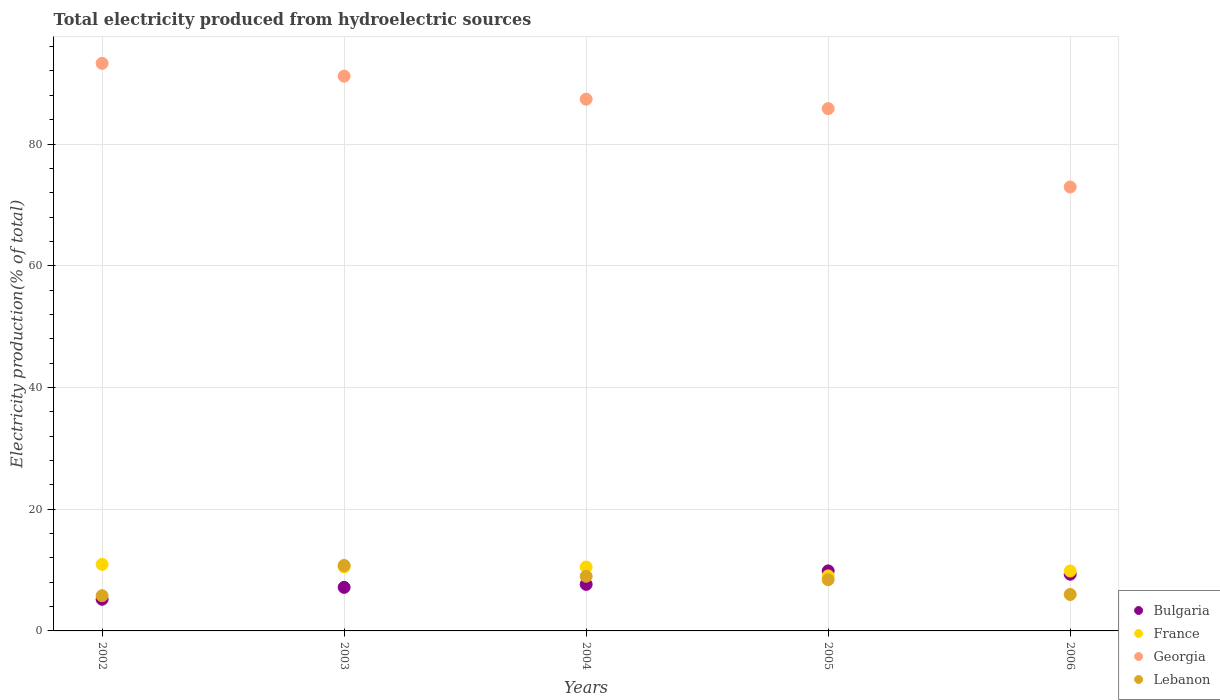How many different coloured dotlines are there?
Your answer should be compact. 4. What is the total electricity produced in Bulgaria in 2005?
Your response must be concise. 9.86. Across all years, what is the maximum total electricity produced in Bulgaria?
Your answer should be compact. 9.86. Across all years, what is the minimum total electricity produced in Bulgaria?
Offer a very short reply. 5.2. In which year was the total electricity produced in Georgia maximum?
Provide a succinct answer. 2002. What is the total total electricity produced in Bulgaria in the graph?
Your answer should be very brief. 39.18. What is the difference between the total electricity produced in France in 2004 and that in 2006?
Your response must be concise. 0.66. What is the difference between the total electricity produced in Georgia in 2006 and the total electricity produced in France in 2004?
Keep it short and to the point. 62.43. What is the average total electricity produced in Bulgaria per year?
Make the answer very short. 7.84. In the year 2003, what is the difference between the total electricity produced in Georgia and total electricity produced in Bulgaria?
Your answer should be very brief. 83.99. In how many years, is the total electricity produced in Lebanon greater than 16 %?
Give a very brief answer. 0. What is the ratio of the total electricity produced in Bulgaria in 2002 to that in 2006?
Provide a short and direct response. 0.56. Is the total electricity produced in Lebanon in 2003 less than that in 2004?
Make the answer very short. No. Is the difference between the total electricity produced in Georgia in 2004 and 2006 greater than the difference between the total electricity produced in Bulgaria in 2004 and 2006?
Keep it short and to the point. Yes. What is the difference between the highest and the second highest total electricity produced in Bulgaria?
Make the answer very short. 0.55. What is the difference between the highest and the lowest total electricity produced in Bulgaria?
Your answer should be compact. 4.66. In how many years, is the total electricity produced in Georgia greater than the average total electricity produced in Georgia taken over all years?
Make the answer very short. 3. Is the sum of the total electricity produced in Lebanon in 2003 and 2006 greater than the maximum total electricity produced in Bulgaria across all years?
Make the answer very short. Yes. Is it the case that in every year, the sum of the total electricity produced in Georgia and total electricity produced in France  is greater than the sum of total electricity produced in Bulgaria and total electricity produced in Lebanon?
Make the answer very short. Yes. Does the total electricity produced in Bulgaria monotonically increase over the years?
Offer a very short reply. No. Is the total electricity produced in Georgia strictly less than the total electricity produced in France over the years?
Ensure brevity in your answer.  No. How many dotlines are there?
Your answer should be compact. 4. What is the difference between two consecutive major ticks on the Y-axis?
Provide a succinct answer. 20. Does the graph contain grids?
Offer a very short reply. Yes. How many legend labels are there?
Your answer should be very brief. 4. What is the title of the graph?
Keep it short and to the point. Total electricity produced from hydroelectric sources. Does "Curacao" appear as one of the legend labels in the graph?
Make the answer very short. No. What is the label or title of the X-axis?
Your answer should be compact. Years. What is the label or title of the Y-axis?
Provide a short and direct response. Electricity production(% of total). What is the Electricity production(% of total) in Bulgaria in 2002?
Offer a terse response. 5.2. What is the Electricity production(% of total) in France in 2002?
Provide a short and direct response. 10.93. What is the Electricity production(% of total) in Georgia in 2002?
Offer a very short reply. 93.25. What is the Electricity production(% of total) in Lebanon in 2002?
Ensure brevity in your answer.  5.78. What is the Electricity production(% of total) of Bulgaria in 2003?
Keep it short and to the point. 7.16. What is the Electricity production(% of total) of France in 2003?
Your answer should be compact. 10.51. What is the Electricity production(% of total) of Georgia in 2003?
Provide a succinct answer. 91.15. What is the Electricity production(% of total) in Lebanon in 2003?
Make the answer very short. 10.75. What is the Electricity production(% of total) of Bulgaria in 2004?
Ensure brevity in your answer.  7.65. What is the Electricity production(% of total) of France in 2004?
Keep it short and to the point. 10.51. What is the Electricity production(% of total) in Georgia in 2004?
Provide a succinct answer. 87.36. What is the Electricity production(% of total) in Lebanon in 2004?
Offer a very short reply. 8.98. What is the Electricity production(% of total) in Bulgaria in 2005?
Provide a succinct answer. 9.86. What is the Electricity production(% of total) of France in 2005?
Make the answer very short. 9.04. What is the Electricity production(% of total) of Georgia in 2005?
Ensure brevity in your answer.  85.81. What is the Electricity production(% of total) of Lebanon in 2005?
Your response must be concise. 8.41. What is the Electricity production(% of total) in Bulgaria in 2006?
Ensure brevity in your answer.  9.31. What is the Electricity production(% of total) in France in 2006?
Keep it short and to the point. 9.85. What is the Electricity production(% of total) of Georgia in 2006?
Give a very brief answer. 72.94. What is the Electricity production(% of total) in Lebanon in 2006?
Give a very brief answer. 5.99. Across all years, what is the maximum Electricity production(% of total) in Bulgaria?
Offer a terse response. 9.86. Across all years, what is the maximum Electricity production(% of total) of France?
Provide a succinct answer. 10.93. Across all years, what is the maximum Electricity production(% of total) of Georgia?
Keep it short and to the point. 93.25. Across all years, what is the maximum Electricity production(% of total) of Lebanon?
Your response must be concise. 10.75. Across all years, what is the minimum Electricity production(% of total) of Bulgaria?
Provide a short and direct response. 5.2. Across all years, what is the minimum Electricity production(% of total) of France?
Give a very brief answer. 9.04. Across all years, what is the minimum Electricity production(% of total) in Georgia?
Your answer should be very brief. 72.94. Across all years, what is the minimum Electricity production(% of total) in Lebanon?
Offer a very short reply. 5.78. What is the total Electricity production(% of total) in Bulgaria in the graph?
Ensure brevity in your answer.  39.18. What is the total Electricity production(% of total) of France in the graph?
Your answer should be compact. 50.83. What is the total Electricity production(% of total) of Georgia in the graph?
Make the answer very short. 430.51. What is the total Electricity production(% of total) in Lebanon in the graph?
Ensure brevity in your answer.  39.91. What is the difference between the Electricity production(% of total) of Bulgaria in 2002 and that in 2003?
Provide a succinct answer. -1.95. What is the difference between the Electricity production(% of total) in France in 2002 and that in 2003?
Give a very brief answer. 0.42. What is the difference between the Electricity production(% of total) in Georgia in 2002 and that in 2003?
Your response must be concise. 2.1. What is the difference between the Electricity production(% of total) of Lebanon in 2002 and that in 2003?
Ensure brevity in your answer.  -4.97. What is the difference between the Electricity production(% of total) in Bulgaria in 2002 and that in 2004?
Provide a short and direct response. -2.44. What is the difference between the Electricity production(% of total) of France in 2002 and that in 2004?
Give a very brief answer. 0.42. What is the difference between the Electricity production(% of total) of Georgia in 2002 and that in 2004?
Make the answer very short. 5.89. What is the difference between the Electricity production(% of total) of Lebanon in 2002 and that in 2004?
Offer a very short reply. -3.19. What is the difference between the Electricity production(% of total) in Bulgaria in 2002 and that in 2005?
Provide a short and direct response. -4.66. What is the difference between the Electricity production(% of total) of France in 2002 and that in 2005?
Provide a succinct answer. 1.89. What is the difference between the Electricity production(% of total) of Georgia in 2002 and that in 2005?
Your answer should be very brief. 7.44. What is the difference between the Electricity production(% of total) of Lebanon in 2002 and that in 2005?
Keep it short and to the point. -2.63. What is the difference between the Electricity production(% of total) of Bulgaria in 2002 and that in 2006?
Give a very brief answer. -4.11. What is the difference between the Electricity production(% of total) of France in 2002 and that in 2006?
Give a very brief answer. 1.08. What is the difference between the Electricity production(% of total) in Georgia in 2002 and that in 2006?
Ensure brevity in your answer.  20.31. What is the difference between the Electricity production(% of total) in Lebanon in 2002 and that in 2006?
Ensure brevity in your answer.  -0.2. What is the difference between the Electricity production(% of total) of Bulgaria in 2003 and that in 2004?
Offer a very short reply. -0.49. What is the difference between the Electricity production(% of total) in France in 2003 and that in 2004?
Keep it short and to the point. 0. What is the difference between the Electricity production(% of total) in Georgia in 2003 and that in 2004?
Offer a very short reply. 3.78. What is the difference between the Electricity production(% of total) of Lebanon in 2003 and that in 2004?
Your answer should be very brief. 1.78. What is the difference between the Electricity production(% of total) in Bulgaria in 2003 and that in 2005?
Your answer should be compact. -2.71. What is the difference between the Electricity production(% of total) in France in 2003 and that in 2005?
Provide a succinct answer. 1.47. What is the difference between the Electricity production(% of total) in Georgia in 2003 and that in 2005?
Your response must be concise. 5.33. What is the difference between the Electricity production(% of total) of Lebanon in 2003 and that in 2005?
Give a very brief answer. 2.34. What is the difference between the Electricity production(% of total) of Bulgaria in 2003 and that in 2006?
Give a very brief answer. -2.16. What is the difference between the Electricity production(% of total) in France in 2003 and that in 2006?
Make the answer very short. 0.66. What is the difference between the Electricity production(% of total) in Georgia in 2003 and that in 2006?
Make the answer very short. 18.21. What is the difference between the Electricity production(% of total) of Lebanon in 2003 and that in 2006?
Your response must be concise. 4.77. What is the difference between the Electricity production(% of total) of Bulgaria in 2004 and that in 2005?
Offer a terse response. -2.22. What is the difference between the Electricity production(% of total) of France in 2004 and that in 2005?
Provide a succinct answer. 1.47. What is the difference between the Electricity production(% of total) of Georgia in 2004 and that in 2005?
Provide a short and direct response. 1.55. What is the difference between the Electricity production(% of total) of Lebanon in 2004 and that in 2005?
Your response must be concise. 0.56. What is the difference between the Electricity production(% of total) of Bulgaria in 2004 and that in 2006?
Give a very brief answer. -1.67. What is the difference between the Electricity production(% of total) of France in 2004 and that in 2006?
Keep it short and to the point. 0.66. What is the difference between the Electricity production(% of total) in Georgia in 2004 and that in 2006?
Keep it short and to the point. 14.42. What is the difference between the Electricity production(% of total) of Lebanon in 2004 and that in 2006?
Give a very brief answer. 2.99. What is the difference between the Electricity production(% of total) in Bulgaria in 2005 and that in 2006?
Your answer should be compact. 0.55. What is the difference between the Electricity production(% of total) in France in 2005 and that in 2006?
Ensure brevity in your answer.  -0.8. What is the difference between the Electricity production(% of total) of Georgia in 2005 and that in 2006?
Make the answer very short. 12.87. What is the difference between the Electricity production(% of total) in Lebanon in 2005 and that in 2006?
Your answer should be very brief. 2.43. What is the difference between the Electricity production(% of total) in Bulgaria in 2002 and the Electricity production(% of total) in France in 2003?
Offer a terse response. -5.31. What is the difference between the Electricity production(% of total) in Bulgaria in 2002 and the Electricity production(% of total) in Georgia in 2003?
Keep it short and to the point. -85.94. What is the difference between the Electricity production(% of total) of Bulgaria in 2002 and the Electricity production(% of total) of Lebanon in 2003?
Provide a succinct answer. -5.55. What is the difference between the Electricity production(% of total) in France in 2002 and the Electricity production(% of total) in Georgia in 2003?
Your answer should be very brief. -80.22. What is the difference between the Electricity production(% of total) of France in 2002 and the Electricity production(% of total) of Lebanon in 2003?
Give a very brief answer. 0.18. What is the difference between the Electricity production(% of total) of Georgia in 2002 and the Electricity production(% of total) of Lebanon in 2003?
Offer a very short reply. 82.49. What is the difference between the Electricity production(% of total) of Bulgaria in 2002 and the Electricity production(% of total) of France in 2004?
Make the answer very short. -5.3. What is the difference between the Electricity production(% of total) in Bulgaria in 2002 and the Electricity production(% of total) in Georgia in 2004?
Make the answer very short. -82.16. What is the difference between the Electricity production(% of total) of Bulgaria in 2002 and the Electricity production(% of total) of Lebanon in 2004?
Your answer should be compact. -3.77. What is the difference between the Electricity production(% of total) of France in 2002 and the Electricity production(% of total) of Georgia in 2004?
Give a very brief answer. -76.43. What is the difference between the Electricity production(% of total) in France in 2002 and the Electricity production(% of total) in Lebanon in 2004?
Ensure brevity in your answer.  1.95. What is the difference between the Electricity production(% of total) of Georgia in 2002 and the Electricity production(% of total) of Lebanon in 2004?
Provide a short and direct response. 84.27. What is the difference between the Electricity production(% of total) in Bulgaria in 2002 and the Electricity production(% of total) in France in 2005?
Your answer should be very brief. -3.84. What is the difference between the Electricity production(% of total) in Bulgaria in 2002 and the Electricity production(% of total) in Georgia in 2005?
Provide a succinct answer. -80.61. What is the difference between the Electricity production(% of total) of Bulgaria in 2002 and the Electricity production(% of total) of Lebanon in 2005?
Provide a succinct answer. -3.21. What is the difference between the Electricity production(% of total) in France in 2002 and the Electricity production(% of total) in Georgia in 2005?
Provide a short and direct response. -74.88. What is the difference between the Electricity production(% of total) of France in 2002 and the Electricity production(% of total) of Lebanon in 2005?
Make the answer very short. 2.52. What is the difference between the Electricity production(% of total) in Georgia in 2002 and the Electricity production(% of total) in Lebanon in 2005?
Keep it short and to the point. 84.83. What is the difference between the Electricity production(% of total) of Bulgaria in 2002 and the Electricity production(% of total) of France in 2006?
Give a very brief answer. -4.64. What is the difference between the Electricity production(% of total) in Bulgaria in 2002 and the Electricity production(% of total) in Georgia in 2006?
Provide a succinct answer. -67.74. What is the difference between the Electricity production(% of total) in Bulgaria in 2002 and the Electricity production(% of total) in Lebanon in 2006?
Give a very brief answer. -0.78. What is the difference between the Electricity production(% of total) of France in 2002 and the Electricity production(% of total) of Georgia in 2006?
Provide a short and direct response. -62.01. What is the difference between the Electricity production(% of total) of France in 2002 and the Electricity production(% of total) of Lebanon in 2006?
Offer a very short reply. 4.94. What is the difference between the Electricity production(% of total) in Georgia in 2002 and the Electricity production(% of total) in Lebanon in 2006?
Keep it short and to the point. 87.26. What is the difference between the Electricity production(% of total) in Bulgaria in 2003 and the Electricity production(% of total) in France in 2004?
Your answer should be very brief. -3.35. What is the difference between the Electricity production(% of total) in Bulgaria in 2003 and the Electricity production(% of total) in Georgia in 2004?
Offer a very short reply. -80.21. What is the difference between the Electricity production(% of total) in Bulgaria in 2003 and the Electricity production(% of total) in Lebanon in 2004?
Your answer should be compact. -1.82. What is the difference between the Electricity production(% of total) of France in 2003 and the Electricity production(% of total) of Georgia in 2004?
Offer a terse response. -76.85. What is the difference between the Electricity production(% of total) in France in 2003 and the Electricity production(% of total) in Lebanon in 2004?
Offer a very short reply. 1.53. What is the difference between the Electricity production(% of total) in Georgia in 2003 and the Electricity production(% of total) in Lebanon in 2004?
Ensure brevity in your answer.  82.17. What is the difference between the Electricity production(% of total) in Bulgaria in 2003 and the Electricity production(% of total) in France in 2005?
Provide a succinct answer. -1.89. What is the difference between the Electricity production(% of total) of Bulgaria in 2003 and the Electricity production(% of total) of Georgia in 2005?
Provide a short and direct response. -78.66. What is the difference between the Electricity production(% of total) of Bulgaria in 2003 and the Electricity production(% of total) of Lebanon in 2005?
Offer a very short reply. -1.26. What is the difference between the Electricity production(% of total) of France in 2003 and the Electricity production(% of total) of Georgia in 2005?
Provide a short and direct response. -75.3. What is the difference between the Electricity production(% of total) in France in 2003 and the Electricity production(% of total) in Lebanon in 2005?
Your answer should be very brief. 2.1. What is the difference between the Electricity production(% of total) in Georgia in 2003 and the Electricity production(% of total) in Lebanon in 2005?
Make the answer very short. 82.73. What is the difference between the Electricity production(% of total) in Bulgaria in 2003 and the Electricity production(% of total) in France in 2006?
Keep it short and to the point. -2.69. What is the difference between the Electricity production(% of total) in Bulgaria in 2003 and the Electricity production(% of total) in Georgia in 2006?
Offer a very short reply. -65.78. What is the difference between the Electricity production(% of total) in Bulgaria in 2003 and the Electricity production(% of total) in Lebanon in 2006?
Your answer should be compact. 1.17. What is the difference between the Electricity production(% of total) in France in 2003 and the Electricity production(% of total) in Georgia in 2006?
Offer a very short reply. -62.43. What is the difference between the Electricity production(% of total) of France in 2003 and the Electricity production(% of total) of Lebanon in 2006?
Ensure brevity in your answer.  4.52. What is the difference between the Electricity production(% of total) of Georgia in 2003 and the Electricity production(% of total) of Lebanon in 2006?
Your answer should be compact. 85.16. What is the difference between the Electricity production(% of total) in Bulgaria in 2004 and the Electricity production(% of total) in France in 2005?
Provide a succinct answer. -1.39. What is the difference between the Electricity production(% of total) in Bulgaria in 2004 and the Electricity production(% of total) in Georgia in 2005?
Your answer should be compact. -78.17. What is the difference between the Electricity production(% of total) in Bulgaria in 2004 and the Electricity production(% of total) in Lebanon in 2005?
Your response must be concise. -0.77. What is the difference between the Electricity production(% of total) in France in 2004 and the Electricity production(% of total) in Georgia in 2005?
Your answer should be very brief. -75.31. What is the difference between the Electricity production(% of total) of France in 2004 and the Electricity production(% of total) of Lebanon in 2005?
Give a very brief answer. 2.09. What is the difference between the Electricity production(% of total) in Georgia in 2004 and the Electricity production(% of total) in Lebanon in 2005?
Offer a terse response. 78.95. What is the difference between the Electricity production(% of total) of Bulgaria in 2004 and the Electricity production(% of total) of France in 2006?
Your response must be concise. -2.2. What is the difference between the Electricity production(% of total) in Bulgaria in 2004 and the Electricity production(% of total) in Georgia in 2006?
Make the answer very short. -65.29. What is the difference between the Electricity production(% of total) of Bulgaria in 2004 and the Electricity production(% of total) of Lebanon in 2006?
Give a very brief answer. 1.66. What is the difference between the Electricity production(% of total) in France in 2004 and the Electricity production(% of total) in Georgia in 2006?
Your answer should be compact. -62.43. What is the difference between the Electricity production(% of total) of France in 2004 and the Electricity production(% of total) of Lebanon in 2006?
Keep it short and to the point. 4.52. What is the difference between the Electricity production(% of total) in Georgia in 2004 and the Electricity production(% of total) in Lebanon in 2006?
Your response must be concise. 81.38. What is the difference between the Electricity production(% of total) in Bulgaria in 2005 and the Electricity production(% of total) in France in 2006?
Your answer should be compact. 0.02. What is the difference between the Electricity production(% of total) in Bulgaria in 2005 and the Electricity production(% of total) in Georgia in 2006?
Provide a succinct answer. -63.08. What is the difference between the Electricity production(% of total) in Bulgaria in 2005 and the Electricity production(% of total) in Lebanon in 2006?
Ensure brevity in your answer.  3.88. What is the difference between the Electricity production(% of total) in France in 2005 and the Electricity production(% of total) in Georgia in 2006?
Make the answer very short. -63.9. What is the difference between the Electricity production(% of total) of France in 2005 and the Electricity production(% of total) of Lebanon in 2006?
Provide a short and direct response. 3.06. What is the difference between the Electricity production(% of total) of Georgia in 2005 and the Electricity production(% of total) of Lebanon in 2006?
Your answer should be compact. 79.83. What is the average Electricity production(% of total) in Bulgaria per year?
Your response must be concise. 7.84. What is the average Electricity production(% of total) of France per year?
Your answer should be very brief. 10.17. What is the average Electricity production(% of total) in Georgia per year?
Your answer should be compact. 86.1. What is the average Electricity production(% of total) of Lebanon per year?
Provide a succinct answer. 7.98. In the year 2002, what is the difference between the Electricity production(% of total) in Bulgaria and Electricity production(% of total) in France?
Give a very brief answer. -5.73. In the year 2002, what is the difference between the Electricity production(% of total) in Bulgaria and Electricity production(% of total) in Georgia?
Give a very brief answer. -88.05. In the year 2002, what is the difference between the Electricity production(% of total) of Bulgaria and Electricity production(% of total) of Lebanon?
Ensure brevity in your answer.  -0.58. In the year 2002, what is the difference between the Electricity production(% of total) in France and Electricity production(% of total) in Georgia?
Keep it short and to the point. -82.32. In the year 2002, what is the difference between the Electricity production(% of total) in France and Electricity production(% of total) in Lebanon?
Offer a terse response. 5.15. In the year 2002, what is the difference between the Electricity production(% of total) of Georgia and Electricity production(% of total) of Lebanon?
Your response must be concise. 87.46. In the year 2003, what is the difference between the Electricity production(% of total) of Bulgaria and Electricity production(% of total) of France?
Offer a terse response. -3.35. In the year 2003, what is the difference between the Electricity production(% of total) in Bulgaria and Electricity production(% of total) in Georgia?
Provide a succinct answer. -83.99. In the year 2003, what is the difference between the Electricity production(% of total) of Bulgaria and Electricity production(% of total) of Lebanon?
Give a very brief answer. -3.6. In the year 2003, what is the difference between the Electricity production(% of total) of France and Electricity production(% of total) of Georgia?
Provide a short and direct response. -80.63. In the year 2003, what is the difference between the Electricity production(% of total) in France and Electricity production(% of total) in Lebanon?
Your answer should be compact. -0.24. In the year 2003, what is the difference between the Electricity production(% of total) in Georgia and Electricity production(% of total) in Lebanon?
Offer a terse response. 80.39. In the year 2004, what is the difference between the Electricity production(% of total) in Bulgaria and Electricity production(% of total) in France?
Provide a succinct answer. -2.86. In the year 2004, what is the difference between the Electricity production(% of total) of Bulgaria and Electricity production(% of total) of Georgia?
Provide a short and direct response. -79.72. In the year 2004, what is the difference between the Electricity production(% of total) of Bulgaria and Electricity production(% of total) of Lebanon?
Your answer should be very brief. -1.33. In the year 2004, what is the difference between the Electricity production(% of total) of France and Electricity production(% of total) of Georgia?
Offer a terse response. -76.86. In the year 2004, what is the difference between the Electricity production(% of total) in France and Electricity production(% of total) in Lebanon?
Your response must be concise. 1.53. In the year 2004, what is the difference between the Electricity production(% of total) of Georgia and Electricity production(% of total) of Lebanon?
Offer a terse response. 78.39. In the year 2005, what is the difference between the Electricity production(% of total) in Bulgaria and Electricity production(% of total) in France?
Provide a short and direct response. 0.82. In the year 2005, what is the difference between the Electricity production(% of total) of Bulgaria and Electricity production(% of total) of Georgia?
Provide a short and direct response. -75.95. In the year 2005, what is the difference between the Electricity production(% of total) of Bulgaria and Electricity production(% of total) of Lebanon?
Keep it short and to the point. 1.45. In the year 2005, what is the difference between the Electricity production(% of total) in France and Electricity production(% of total) in Georgia?
Provide a succinct answer. -76.77. In the year 2005, what is the difference between the Electricity production(% of total) of France and Electricity production(% of total) of Lebanon?
Provide a short and direct response. 0.63. In the year 2005, what is the difference between the Electricity production(% of total) in Georgia and Electricity production(% of total) in Lebanon?
Your answer should be compact. 77.4. In the year 2006, what is the difference between the Electricity production(% of total) in Bulgaria and Electricity production(% of total) in France?
Provide a succinct answer. -0.53. In the year 2006, what is the difference between the Electricity production(% of total) of Bulgaria and Electricity production(% of total) of Georgia?
Ensure brevity in your answer.  -63.62. In the year 2006, what is the difference between the Electricity production(% of total) in Bulgaria and Electricity production(% of total) in Lebanon?
Offer a very short reply. 3.33. In the year 2006, what is the difference between the Electricity production(% of total) of France and Electricity production(% of total) of Georgia?
Give a very brief answer. -63.09. In the year 2006, what is the difference between the Electricity production(% of total) of France and Electricity production(% of total) of Lebanon?
Provide a short and direct response. 3.86. In the year 2006, what is the difference between the Electricity production(% of total) of Georgia and Electricity production(% of total) of Lebanon?
Provide a succinct answer. 66.95. What is the ratio of the Electricity production(% of total) of Bulgaria in 2002 to that in 2003?
Your answer should be compact. 0.73. What is the ratio of the Electricity production(% of total) in France in 2002 to that in 2003?
Make the answer very short. 1.04. What is the ratio of the Electricity production(% of total) in Georgia in 2002 to that in 2003?
Ensure brevity in your answer.  1.02. What is the ratio of the Electricity production(% of total) in Lebanon in 2002 to that in 2003?
Your response must be concise. 0.54. What is the ratio of the Electricity production(% of total) in Bulgaria in 2002 to that in 2004?
Provide a short and direct response. 0.68. What is the ratio of the Electricity production(% of total) of France in 2002 to that in 2004?
Make the answer very short. 1.04. What is the ratio of the Electricity production(% of total) in Georgia in 2002 to that in 2004?
Your response must be concise. 1.07. What is the ratio of the Electricity production(% of total) in Lebanon in 2002 to that in 2004?
Give a very brief answer. 0.64. What is the ratio of the Electricity production(% of total) in Bulgaria in 2002 to that in 2005?
Provide a short and direct response. 0.53. What is the ratio of the Electricity production(% of total) of France in 2002 to that in 2005?
Provide a short and direct response. 1.21. What is the ratio of the Electricity production(% of total) in Georgia in 2002 to that in 2005?
Ensure brevity in your answer.  1.09. What is the ratio of the Electricity production(% of total) of Lebanon in 2002 to that in 2005?
Keep it short and to the point. 0.69. What is the ratio of the Electricity production(% of total) in Bulgaria in 2002 to that in 2006?
Ensure brevity in your answer.  0.56. What is the ratio of the Electricity production(% of total) of France in 2002 to that in 2006?
Ensure brevity in your answer.  1.11. What is the ratio of the Electricity production(% of total) in Georgia in 2002 to that in 2006?
Provide a succinct answer. 1.28. What is the ratio of the Electricity production(% of total) of Lebanon in 2002 to that in 2006?
Your response must be concise. 0.97. What is the ratio of the Electricity production(% of total) in Bulgaria in 2003 to that in 2004?
Keep it short and to the point. 0.94. What is the ratio of the Electricity production(% of total) of Georgia in 2003 to that in 2004?
Give a very brief answer. 1.04. What is the ratio of the Electricity production(% of total) of Lebanon in 2003 to that in 2004?
Your answer should be very brief. 1.2. What is the ratio of the Electricity production(% of total) in Bulgaria in 2003 to that in 2005?
Your response must be concise. 0.73. What is the ratio of the Electricity production(% of total) in France in 2003 to that in 2005?
Provide a short and direct response. 1.16. What is the ratio of the Electricity production(% of total) in Georgia in 2003 to that in 2005?
Offer a very short reply. 1.06. What is the ratio of the Electricity production(% of total) of Lebanon in 2003 to that in 2005?
Offer a terse response. 1.28. What is the ratio of the Electricity production(% of total) in Bulgaria in 2003 to that in 2006?
Make the answer very short. 0.77. What is the ratio of the Electricity production(% of total) in France in 2003 to that in 2006?
Give a very brief answer. 1.07. What is the ratio of the Electricity production(% of total) of Georgia in 2003 to that in 2006?
Your answer should be very brief. 1.25. What is the ratio of the Electricity production(% of total) of Lebanon in 2003 to that in 2006?
Give a very brief answer. 1.8. What is the ratio of the Electricity production(% of total) of Bulgaria in 2004 to that in 2005?
Make the answer very short. 0.78. What is the ratio of the Electricity production(% of total) of France in 2004 to that in 2005?
Give a very brief answer. 1.16. What is the ratio of the Electricity production(% of total) in Georgia in 2004 to that in 2005?
Give a very brief answer. 1.02. What is the ratio of the Electricity production(% of total) of Lebanon in 2004 to that in 2005?
Offer a very short reply. 1.07. What is the ratio of the Electricity production(% of total) of Bulgaria in 2004 to that in 2006?
Give a very brief answer. 0.82. What is the ratio of the Electricity production(% of total) of France in 2004 to that in 2006?
Make the answer very short. 1.07. What is the ratio of the Electricity production(% of total) in Georgia in 2004 to that in 2006?
Make the answer very short. 1.2. What is the ratio of the Electricity production(% of total) in Lebanon in 2004 to that in 2006?
Your answer should be compact. 1.5. What is the ratio of the Electricity production(% of total) in Bulgaria in 2005 to that in 2006?
Offer a terse response. 1.06. What is the ratio of the Electricity production(% of total) in France in 2005 to that in 2006?
Your answer should be very brief. 0.92. What is the ratio of the Electricity production(% of total) of Georgia in 2005 to that in 2006?
Provide a short and direct response. 1.18. What is the ratio of the Electricity production(% of total) in Lebanon in 2005 to that in 2006?
Your response must be concise. 1.41. What is the difference between the highest and the second highest Electricity production(% of total) of Bulgaria?
Provide a succinct answer. 0.55. What is the difference between the highest and the second highest Electricity production(% of total) in France?
Offer a terse response. 0.42. What is the difference between the highest and the second highest Electricity production(% of total) in Georgia?
Make the answer very short. 2.1. What is the difference between the highest and the second highest Electricity production(% of total) in Lebanon?
Your response must be concise. 1.78. What is the difference between the highest and the lowest Electricity production(% of total) of Bulgaria?
Make the answer very short. 4.66. What is the difference between the highest and the lowest Electricity production(% of total) of France?
Offer a terse response. 1.89. What is the difference between the highest and the lowest Electricity production(% of total) in Georgia?
Offer a terse response. 20.31. What is the difference between the highest and the lowest Electricity production(% of total) of Lebanon?
Give a very brief answer. 4.97. 